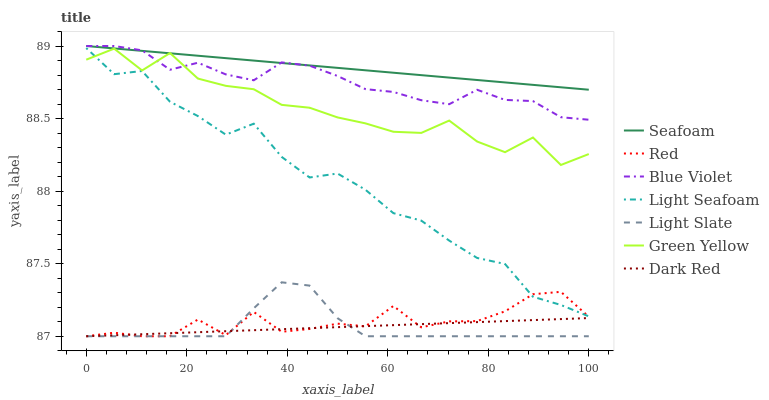Does Light Slate have the minimum area under the curve?
Answer yes or no. Yes. Does Seafoam have the maximum area under the curve?
Answer yes or no. Yes. Does Dark Red have the minimum area under the curve?
Answer yes or no. No. Does Dark Red have the maximum area under the curve?
Answer yes or no. No. Is Dark Red the smoothest?
Answer yes or no. Yes. Is Green Yellow the roughest?
Answer yes or no. Yes. Is Light Slate the smoothest?
Answer yes or no. No. Is Light Slate the roughest?
Answer yes or no. No. Does Light Slate have the lowest value?
Answer yes or no. Yes. Does Seafoam have the lowest value?
Answer yes or no. No. Does Blue Violet have the highest value?
Answer yes or no. Yes. Does Light Slate have the highest value?
Answer yes or no. No. Is Dark Red less than Green Yellow?
Answer yes or no. Yes. Is Seafoam greater than Dark Red?
Answer yes or no. Yes. Does Green Yellow intersect Seafoam?
Answer yes or no. Yes. Is Green Yellow less than Seafoam?
Answer yes or no. No. Is Green Yellow greater than Seafoam?
Answer yes or no. No. Does Dark Red intersect Green Yellow?
Answer yes or no. No. 